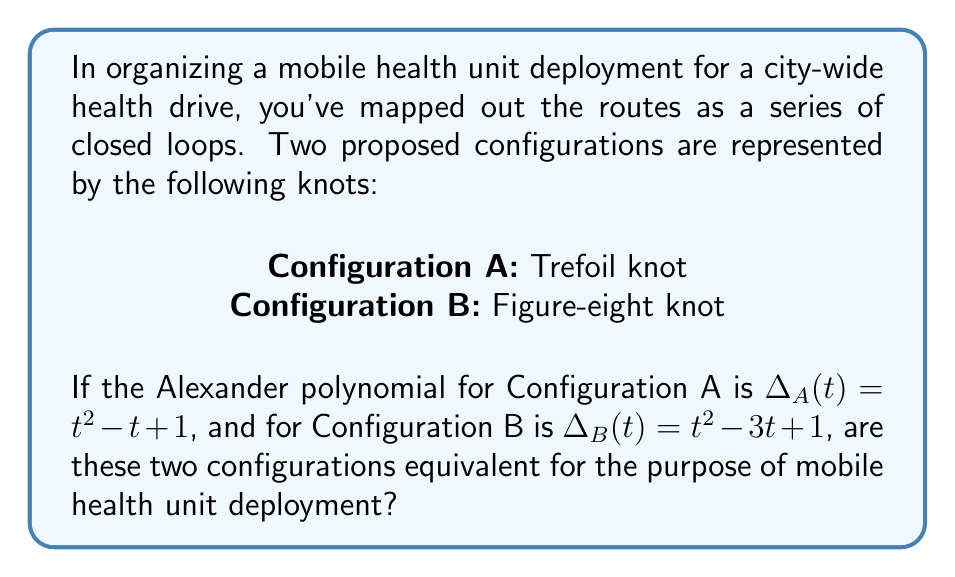What is the answer to this math problem? To determine if the two configurations are equivalent, we need to analyze their knot invariants, specifically the Alexander polynomial in this case. The Alexander polynomial is a knot invariant that can help distinguish between different knots.

Step 1: Identify the given Alexander polynomials
Configuration A (Trefoil knot): $\Delta_A(t) = t^2 - t + 1$
Configuration B (Figure-eight knot): $\Delta_B(t) = t^2 - 3t + 1$

Step 2: Compare the Alexander polynomials
We can see that the Alexander polynomials for Configuration A and Configuration B are different:
$\Delta_A(t) \neq \Delta_B(t)$

Step 3: Interpret the result
Since the Alexander polynomials are different, we can conclude that the knots representing Configurations A and B are not equivalent. In knot theory, if two knots have different Alexander polynomials, they cannot be transformed into each other through a series of Reidemeister moves without cutting and rejoining the knot.

Step 4: Apply to the context of mobile health unit deployment
In the context of mobile health unit deployment, this means that the two configurations represent fundamentally different route structures. They cannot be transformed into each other without altering the basic layout of the deployment routes.
Answer: No, the configurations are not equivalent. 